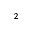Convert formula to latex. <formula><loc_0><loc_0><loc_500><loc_500>_ { 2 }</formula> 